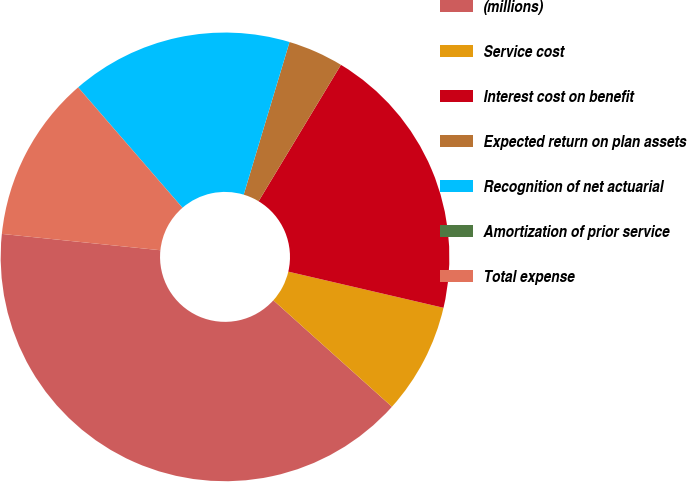Convert chart to OTSL. <chart><loc_0><loc_0><loc_500><loc_500><pie_chart><fcel>(millions)<fcel>Service cost<fcel>Interest cost on benefit<fcel>Expected return on plan assets<fcel>Recognition of net actuarial<fcel>Amortization of prior service<fcel>Total expense<nl><fcel>39.99%<fcel>8.0%<fcel>20.0%<fcel>4.0%<fcel>16.0%<fcel>0.01%<fcel>12.0%<nl></chart> 